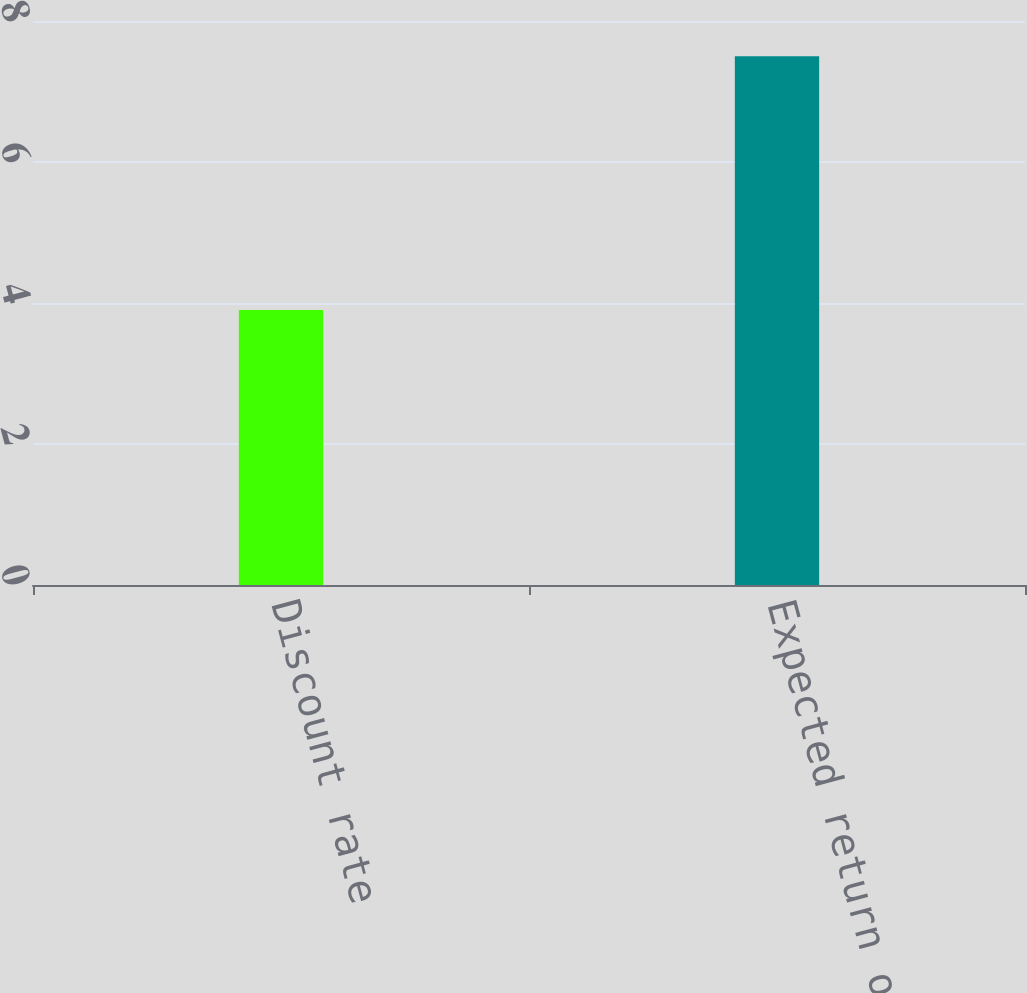<chart> <loc_0><loc_0><loc_500><loc_500><bar_chart><fcel>Discount rate<fcel>Expected return on plan assets<nl><fcel>3.9<fcel>7.5<nl></chart> 